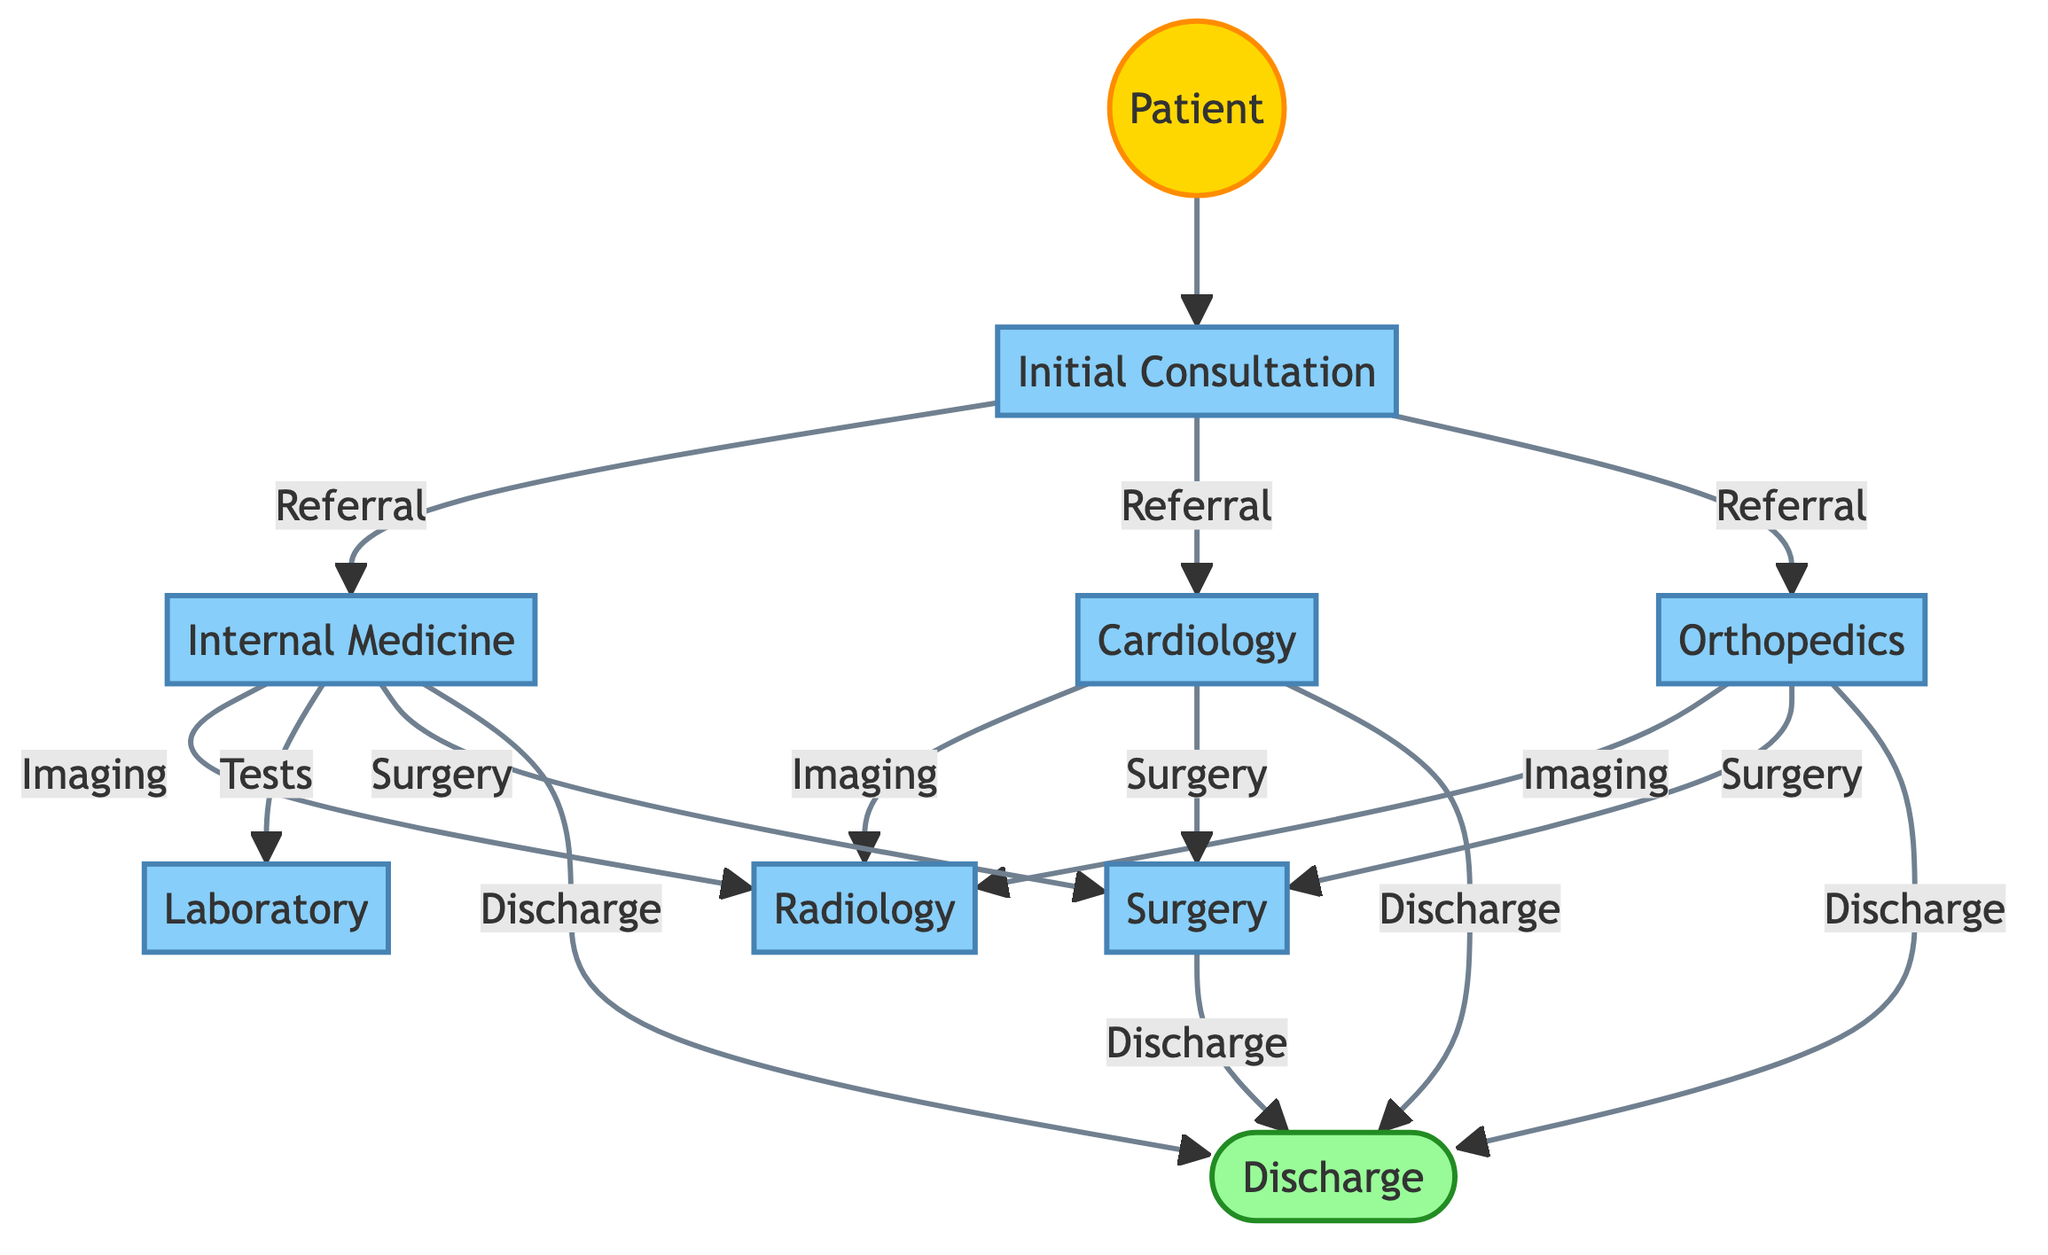What is the first step in the patient referral process? The initial step in the referral process, as indicated in the diagram, involves the patient starting at the "Initial Consultation" node.
Answer: Initial Consultation How many departments are involved in the referral process? By counting the distinct departments listed in the nodes, we see that there are seven departments involved: Internal Medicine, Cardiology, Orthopedics, Radiology, Laboratory, Surgery, and General Medicine (Initial Consultation).
Answer: 7 From the "Initial Consultation" node, which departments can a patient be referred to? The "Initial Consultation" node connects to three departments labeled as "Internal Medicine," "Cardiology," and "Orthopedics," indicating where patients can be referred.
Answer: Internal Medicine, Cardiology, Orthopedics What type of referrals does the "Internal Medicine" department have? The "Internal Medicine" department makes referrals for both "Imaging" (to Radiology) and "Tests" (to Laboratory). This shows the actions taken based on patient needs arising from consultations.
Answer: Imaging, Tests How does a patient exit the referral process? The referral process ends when the patient reaches the "Discharge" node, which connects from several departments, signifying their exit from the hospital system.
Answer: Discharge What is the last department a patient would go through before discharge? According to the diagram, several departments can lead to "Discharge," but the last departments directly connecting to it include Surgery, Orthopedics, Cardiology, and Internal Medicine. Any of these can be the last department before discharge, but Surgery is one example.
Answer: Surgery After a referral from "Internal Medicine" for surgery, what is the next step for the patient? After a referral for surgery from "Internal Medicine," the next step is directed towards the "Surgery" department. The flow indicates that the patient's journey will then lead them to Surgery.
Answer: Surgery Which department has the most direct referrals for imaging from other departments? The "Radiology" department receives referrals for imaging from three separate departments: Internal Medicine, Cardiology, and Orthopedics, which indicates it has the highest connections for this type of service.
Answer: Radiology 